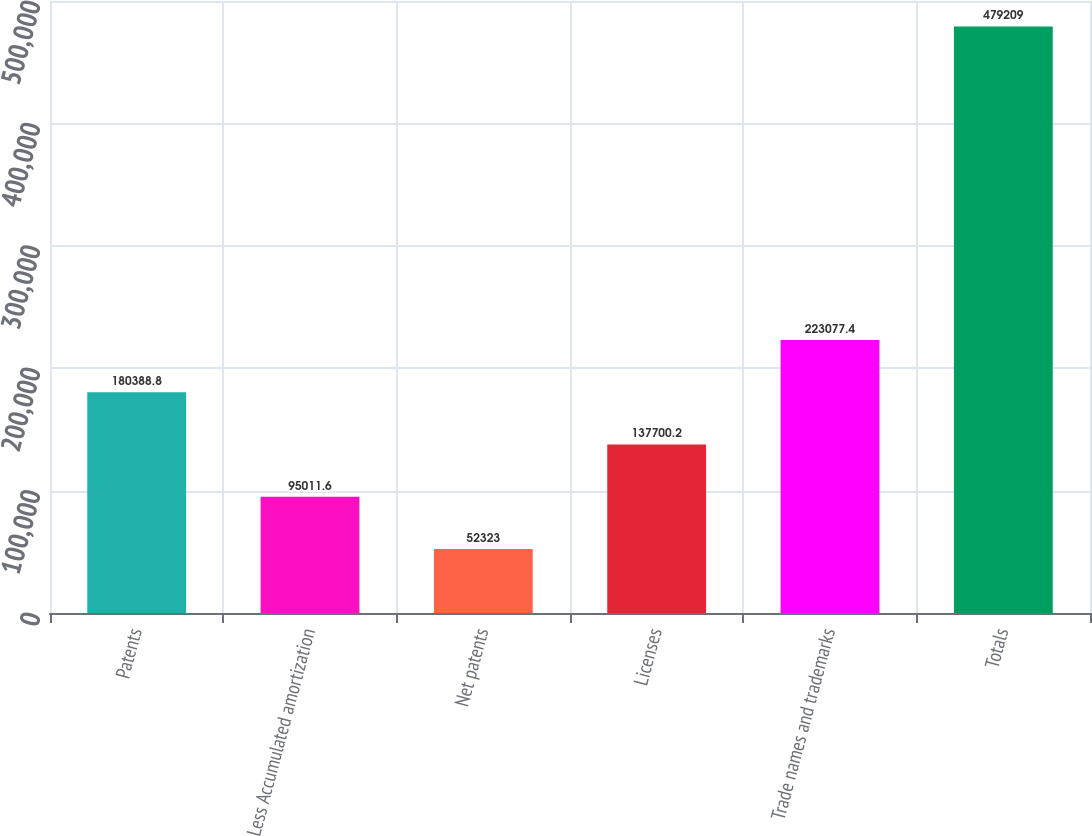Convert chart to OTSL. <chart><loc_0><loc_0><loc_500><loc_500><bar_chart><fcel>Patents<fcel>Less Accumulated amortization<fcel>Net patents<fcel>Licenses<fcel>Trade names and trademarks<fcel>Totals<nl><fcel>180389<fcel>95011.6<fcel>52323<fcel>137700<fcel>223077<fcel>479209<nl></chart> 